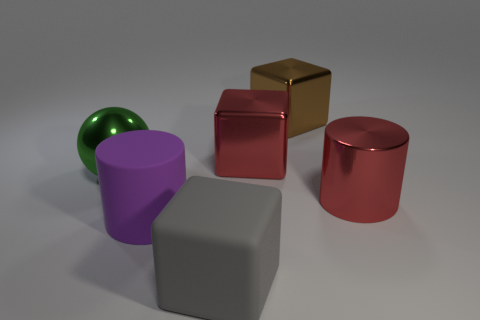Add 3 gray rubber objects. How many objects exist? 9 Subtract all balls. How many objects are left? 5 Subtract all tiny red objects. Subtract all big red metal things. How many objects are left? 4 Add 5 big purple rubber cylinders. How many big purple rubber cylinders are left? 6 Add 1 big green balls. How many big green balls exist? 2 Subtract 0 brown cylinders. How many objects are left? 6 